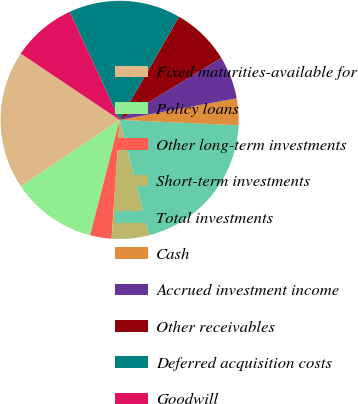Convert chart to OTSL. <chart><loc_0><loc_0><loc_500><loc_500><pie_chart><fcel>Fixed maturities-available for<fcel>Policy loans<fcel>Other long-term investments<fcel>Short-term investments<fcel>Total investments<fcel>Cash<fcel>Accrued investment income<fcel>Other receivables<fcel>Deferred acquisition costs<fcel>Goodwill<nl><fcel>18.83%<fcel>11.59%<fcel>2.91%<fcel>5.08%<fcel>20.27%<fcel>3.63%<fcel>5.8%<fcel>7.97%<fcel>15.21%<fcel>8.7%<nl></chart> 